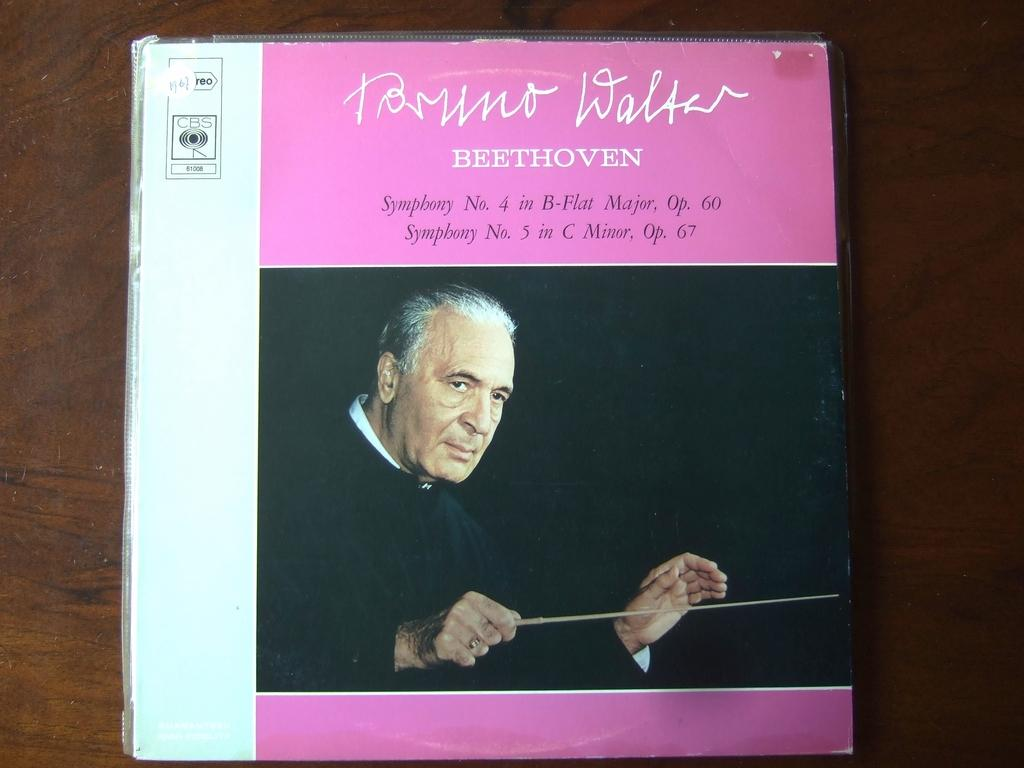<image>
Describe the image concisely. An pink and white album box set of Beethoven's Symponies 4 and 5. 